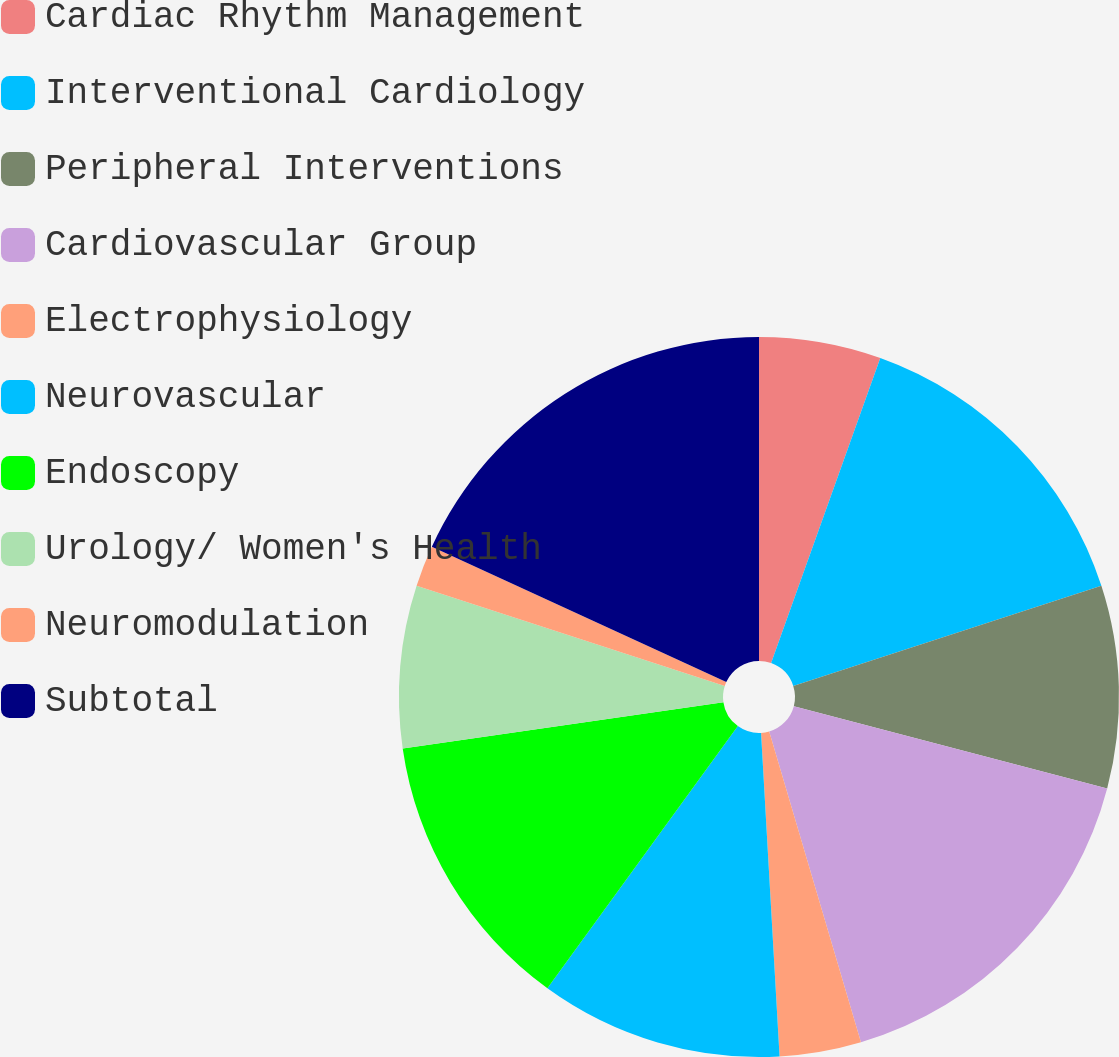Convert chart. <chart><loc_0><loc_0><loc_500><loc_500><pie_chart><fcel>Cardiac Rhythm Management<fcel>Interventional Cardiology<fcel>Peripheral Interventions<fcel>Cardiovascular Group<fcel>Electrophysiology<fcel>Neurovascular<fcel>Endoscopy<fcel>Urology/ Women's Health<fcel>Neuromodulation<fcel>Subtotal<nl><fcel>5.47%<fcel>14.53%<fcel>9.09%<fcel>16.34%<fcel>3.66%<fcel>10.91%<fcel>12.72%<fcel>7.28%<fcel>1.85%<fcel>18.15%<nl></chart> 